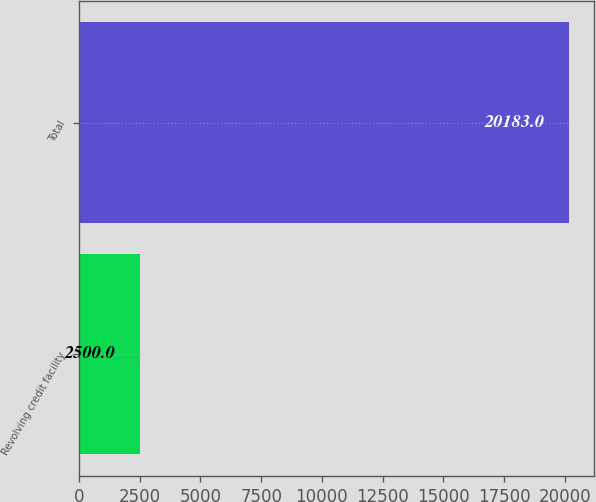Convert chart to OTSL. <chart><loc_0><loc_0><loc_500><loc_500><bar_chart><fcel>Revolving credit facility<fcel>Total<nl><fcel>2500<fcel>20183<nl></chart> 